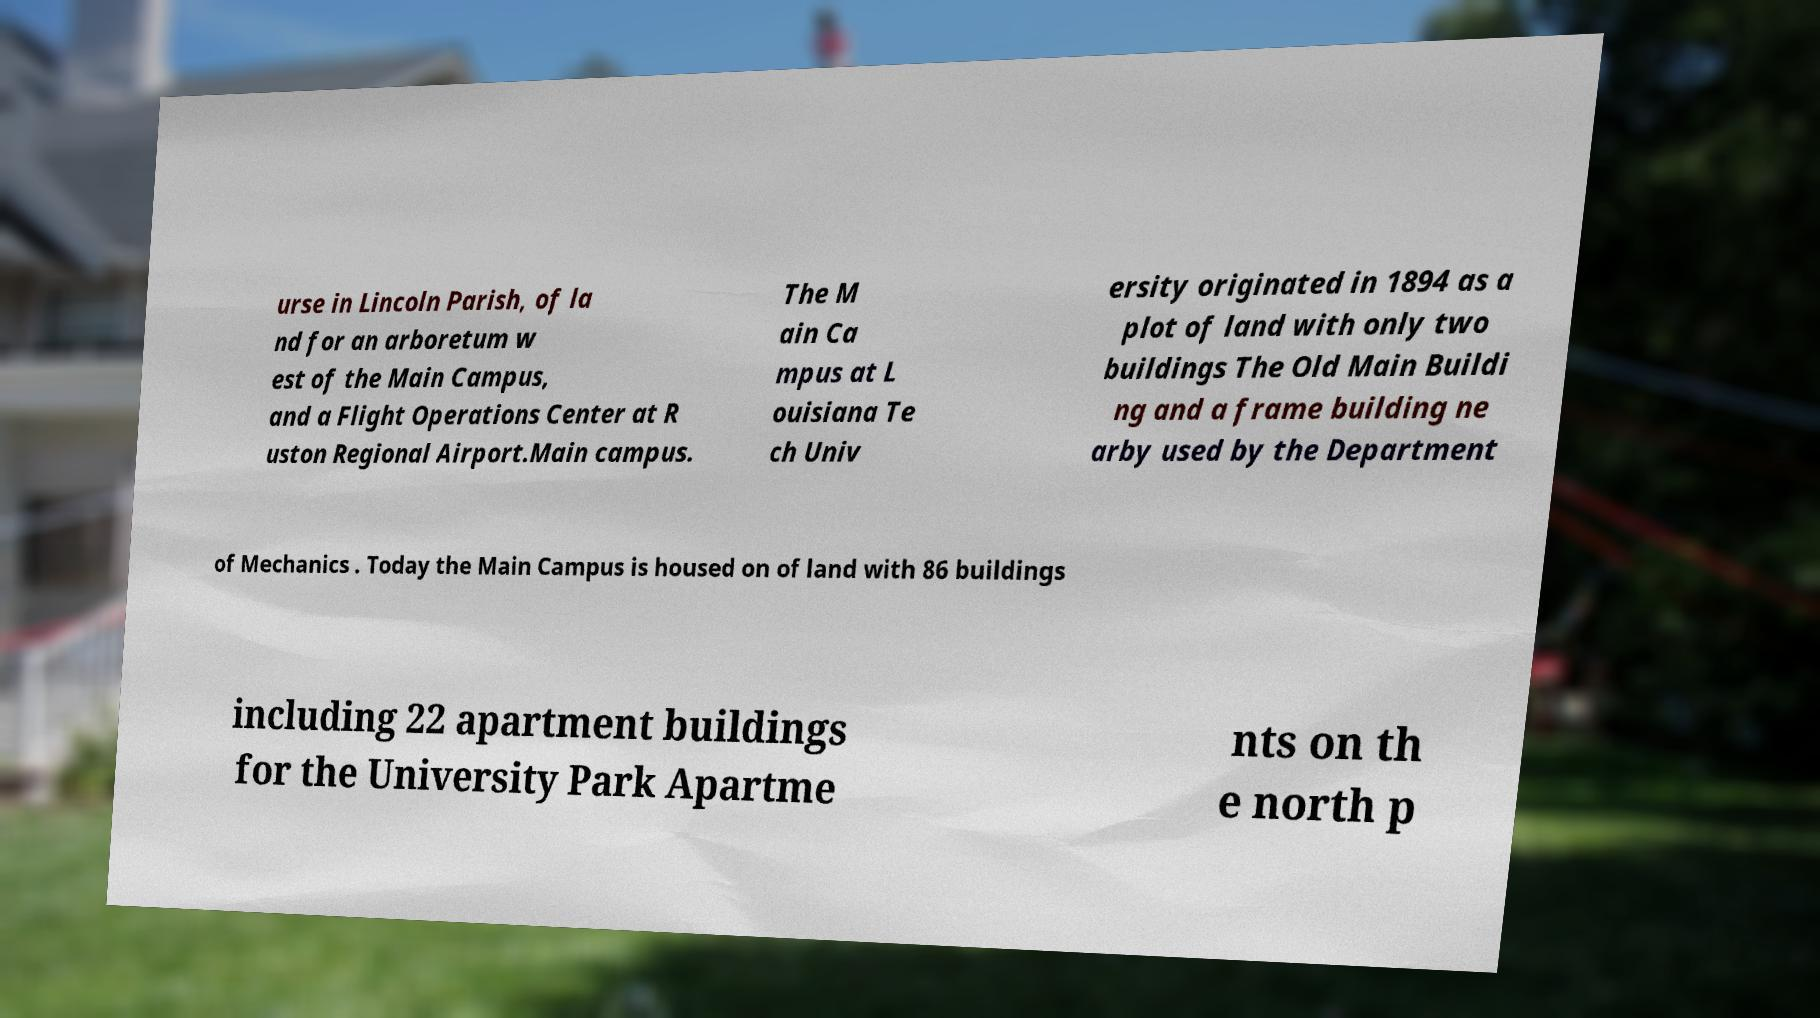Please read and relay the text visible in this image. What does it say? urse in Lincoln Parish, of la nd for an arboretum w est of the Main Campus, and a Flight Operations Center at R uston Regional Airport.Main campus. The M ain Ca mpus at L ouisiana Te ch Univ ersity originated in 1894 as a plot of land with only two buildings The Old Main Buildi ng and a frame building ne arby used by the Department of Mechanics . Today the Main Campus is housed on of land with 86 buildings including 22 apartment buildings for the University Park Apartme nts on th e north p 